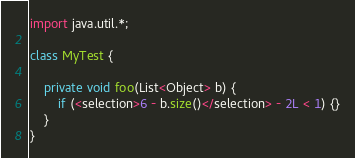<code> <loc_0><loc_0><loc_500><loc_500><_Java_>import java.util.*;

class MyTest {
    
    private void foo(List<Object> b) {
        if (<selection>6 - b.size()</selection> - 2L < 1) {}
    }
}</code> 